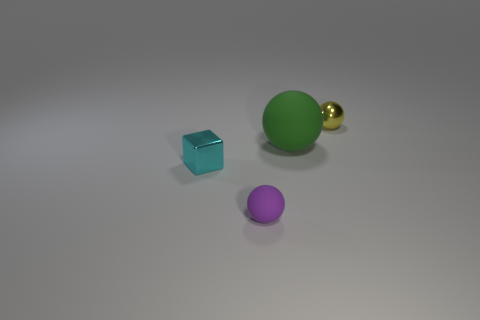Is the number of cyan cubes that are to the right of the tiny rubber ball less than the number of matte balls?
Your response must be concise. Yes. Does the shiny thing behind the metallic block have the same size as the small rubber thing?
Give a very brief answer. Yes. How many small matte things have the same shape as the yellow shiny thing?
Your response must be concise. 1. There is a sphere that is the same material as the cyan thing; what size is it?
Give a very brief answer. Small. Are there an equal number of cyan objects behind the small yellow metal ball and tiny cyan objects?
Provide a short and direct response. No. Does the tiny shiny sphere have the same color as the large rubber thing?
Ensure brevity in your answer.  No. There is a small shiny object that is behind the large ball; is it the same shape as the tiny metal thing that is left of the yellow metal ball?
Provide a succinct answer. No. There is another big object that is the same shape as the yellow metal thing; what is its material?
Your answer should be very brief. Rubber. There is a small object that is in front of the green object and behind the small purple matte sphere; what is its color?
Give a very brief answer. Cyan. Are there any tiny purple spheres that are right of the tiny sphere that is in front of the tiny shiny object behind the small cyan metal thing?
Your answer should be compact. No. 